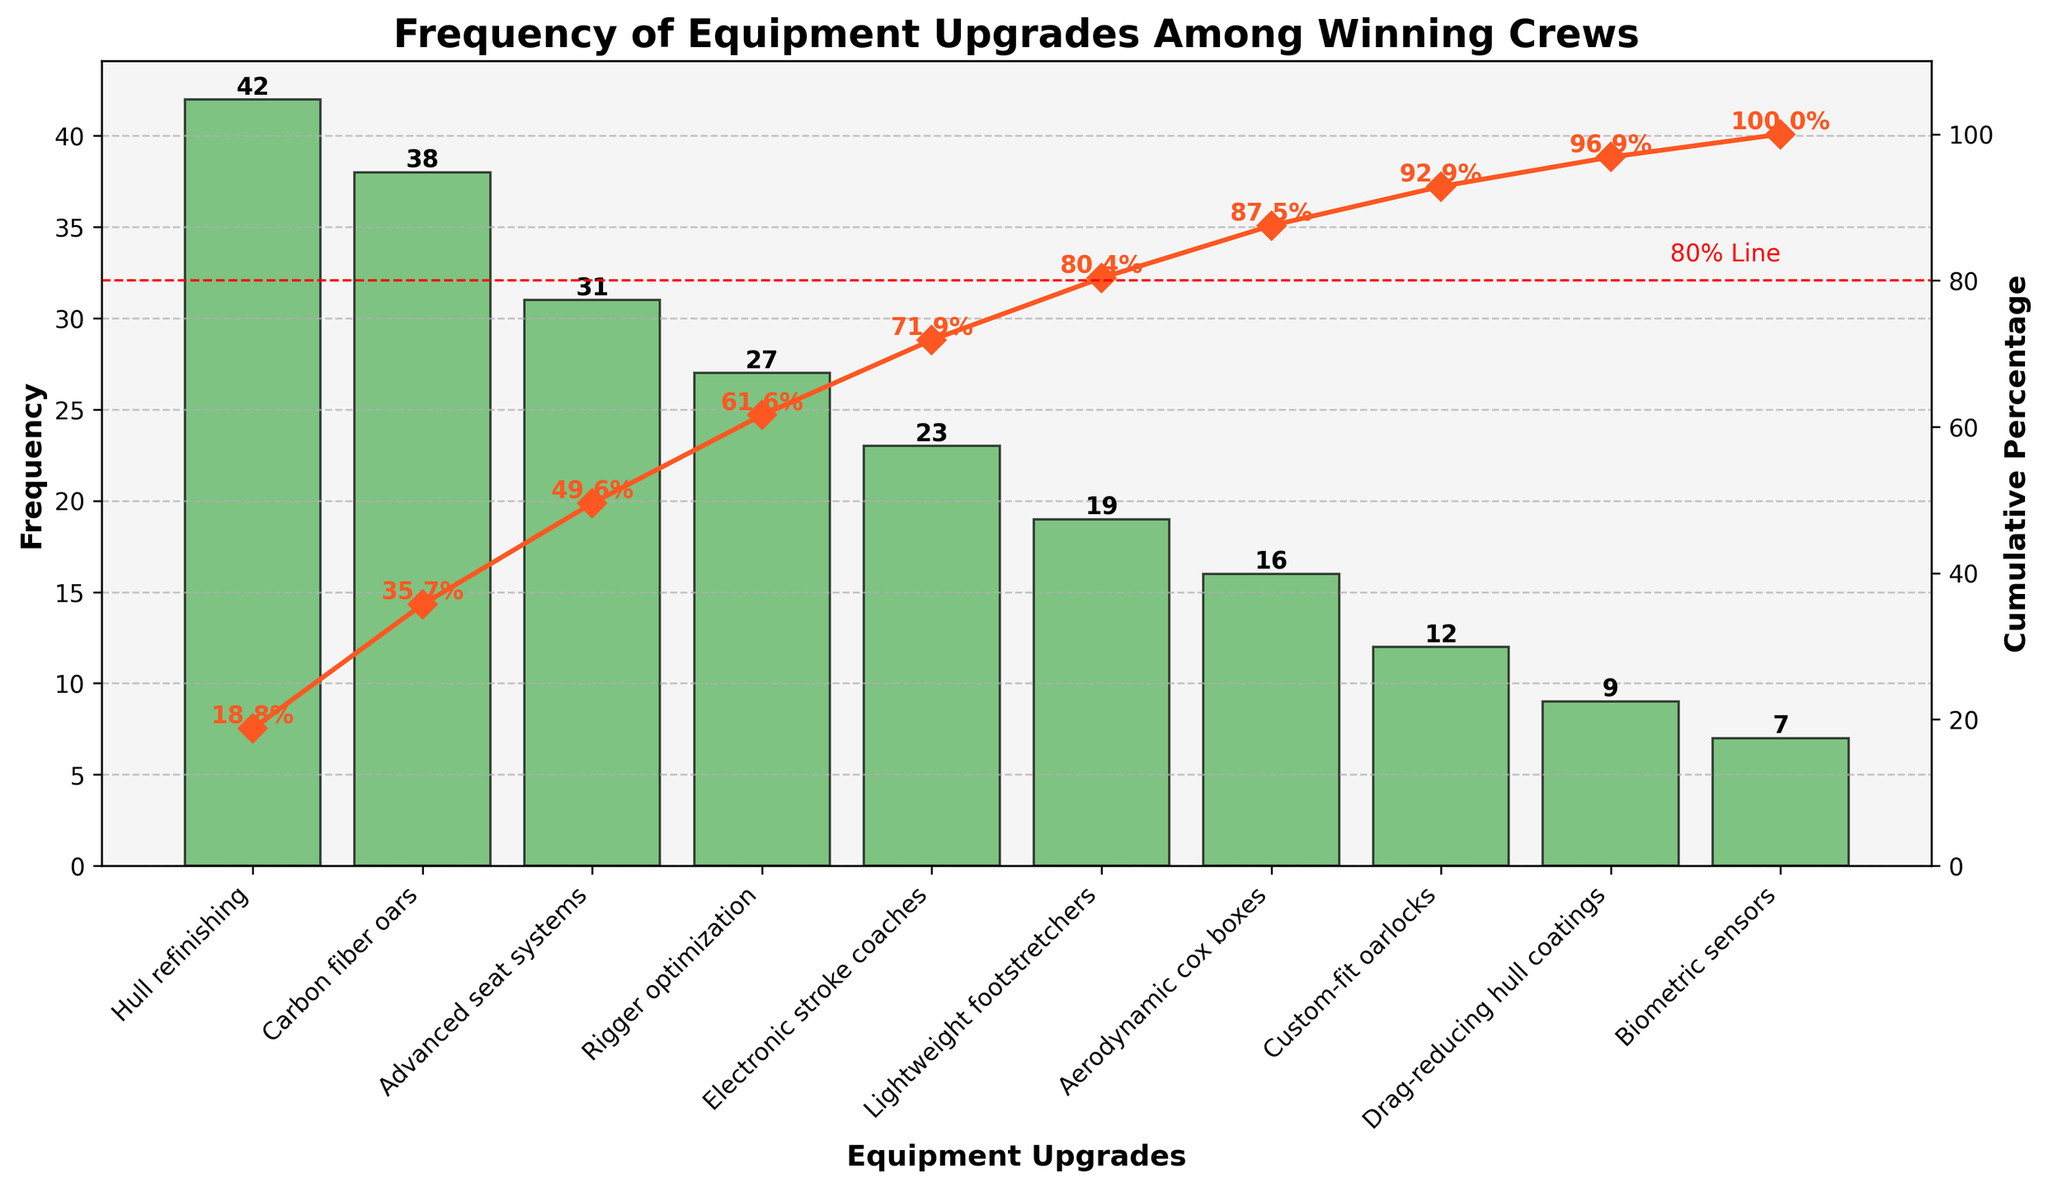What is the most common equipment upgrade among winning crews? According to the plot, Hull refinishing is the highest bar with a frequency of 42.
Answer: Hull refinishing How many total equipment upgrades are represented in the chart? There are 10 different bars representing 10 equipment upgrades.
Answer: 10 Which equipment upgrade has the lowest frequency? The shortest bar on the plot represents Biometric sensors with a frequency of 7.
Answer: Biometric sensors What is the cumulative percentage after the third most frequent equipment upgrade? The cumulative percentage after the third most frequent (Advanced seat systems) can be referenced from the line plot which is approximately 74.7%.
Answer: 74.7% By how much does the frequency of Carbon fiber oars exceed that of Electronic stroke coaches? Carbon fiber oars have a frequency of 38 and Electronic stroke coaches have a frequency of 23. So, the difference is 38 - 23 = 15.
Answer: 15 Which equipment upgrades contribute to the cumulative percentage just above 80%? By looking at the cumulative percentage line plot and the red 80% line, Advanced seat systems reach above 80%, including Hull refinishing, Carbon fiber oars, Advanced seat systems, and Rigger optimization.
Answer: Hull refinishing, Carbon fiber oars, Advanced seat systems, and Rigger optimization What is the combined frequency of the three least common equipment upgrades? The least common are Biometric sensors (7), Drag-reducing hull coatings (9), and Custom-fit oarlocks (12). Combined frequency = 7 + 9 + 12 = 28.
Answer: 28 Which equipment upgrade just surpasses the 50% cumulative percentage mark? Checking the cumulative percentage plot, the upgrade that surpasses 50% is Carbon fiber oars.
Answer: Carbon fiber oars What is the frequency difference between Rigger optimization and Lightweight footstretchers? Rigger optimization has a frequency of 27, and Lightweight footstretchers have a frequency of 19. The difference is 27 - 19 = 8.
Answer: 8 How many equipment upgrades have frequencies in double digits but less than 20? Equipment upgrades between 10 and 19 frequencies are Custom-fit oarlocks (12) and Lightweight footstretchers (19).
Answer: 2 